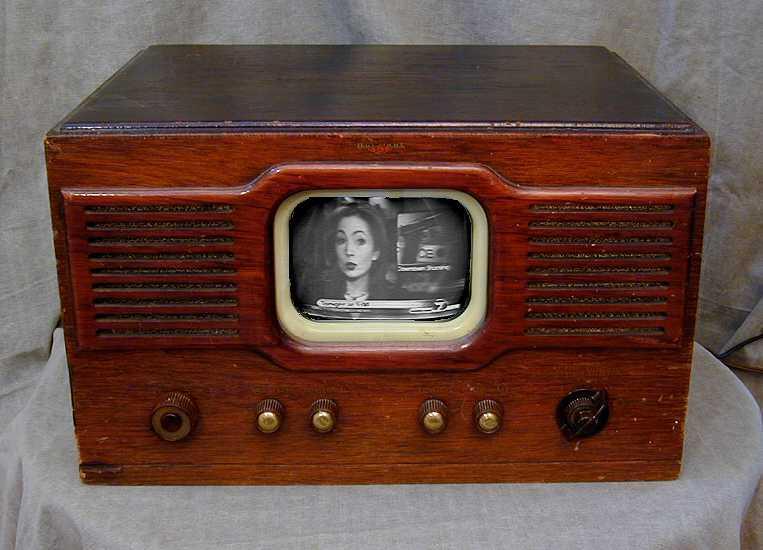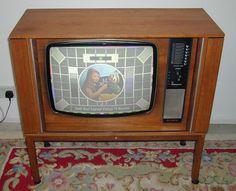The first image is the image on the left, the second image is the image on the right. Assess this claim about the two images: "In at least one image there is a small rectangle tv sitting on a white table.". Correct or not? Answer yes or no. Yes. 